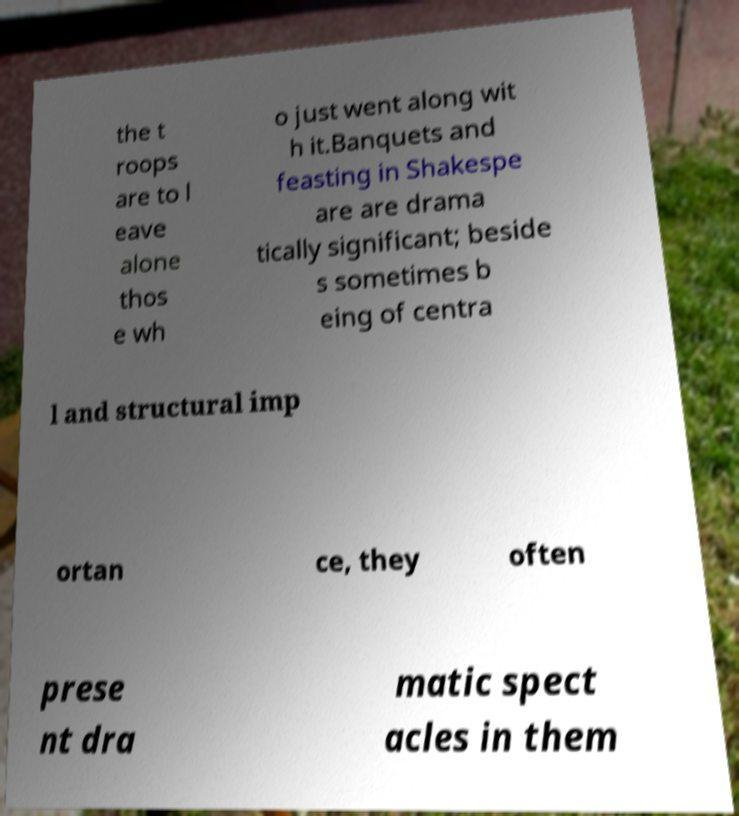Can you read and provide the text displayed in the image?This photo seems to have some interesting text. Can you extract and type it out for me? the t roops are to l eave alone thos e wh o just went along wit h it.Banquets and feasting in Shakespe are are drama tically significant; beside s sometimes b eing of centra l and structural imp ortan ce, they often prese nt dra matic spect acles in them 